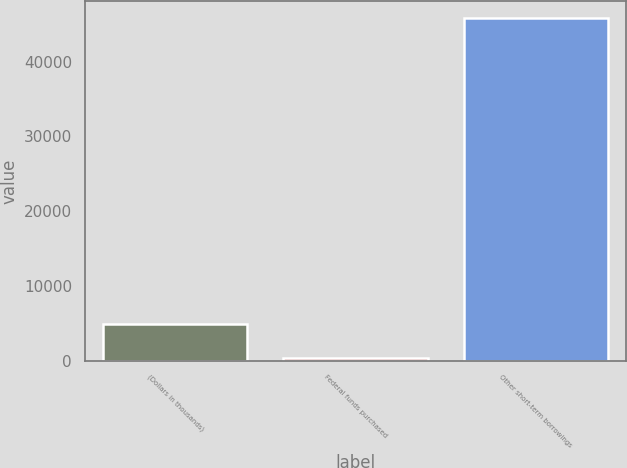Convert chart. <chart><loc_0><loc_0><loc_500><loc_500><bar_chart><fcel>(Dollars in thousands)<fcel>Federal funds purchased<fcel>Other short-term borrowings<nl><fcel>4886.9<fcel>342<fcel>45791<nl></chart> 